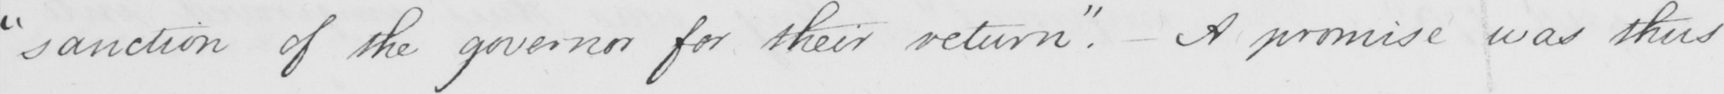Transcribe the text shown in this historical manuscript line. " sanction of the governor for their return "  .  _  A promise was thus 